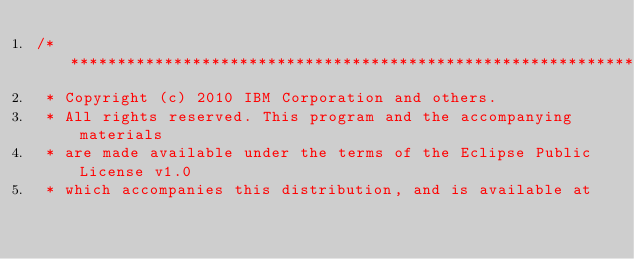<code> <loc_0><loc_0><loc_500><loc_500><_Java_>/*******************************************************************************
 * Copyright (c) 2010 IBM Corporation and others.
 * All rights reserved. This program and the accompanying materials
 * are made available under the terms of the Eclipse Public License v1.0
 * which accompanies this distribution, and is available at</code> 